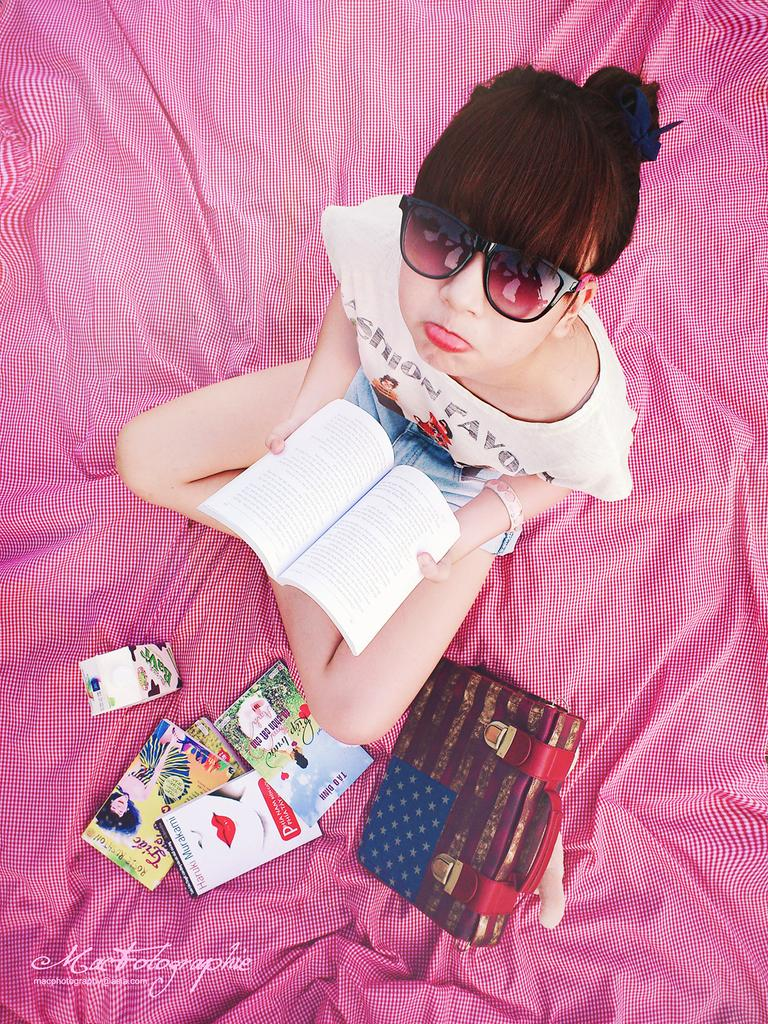What is the person in the image wearing? The person in the image is wearing goggles. What is the person holding in the image? The person is holding a book. What is the person sitting on in the image? The person is sitting on a pink cloth. What is located beside the person in the image? There is a bag beside the person. What else can be seen near the person in the image? There are additional books placed near the person. What type of hill can be seen in the background of the image? There is no hill visible in the image; it is focused on the person and their surroundings. 